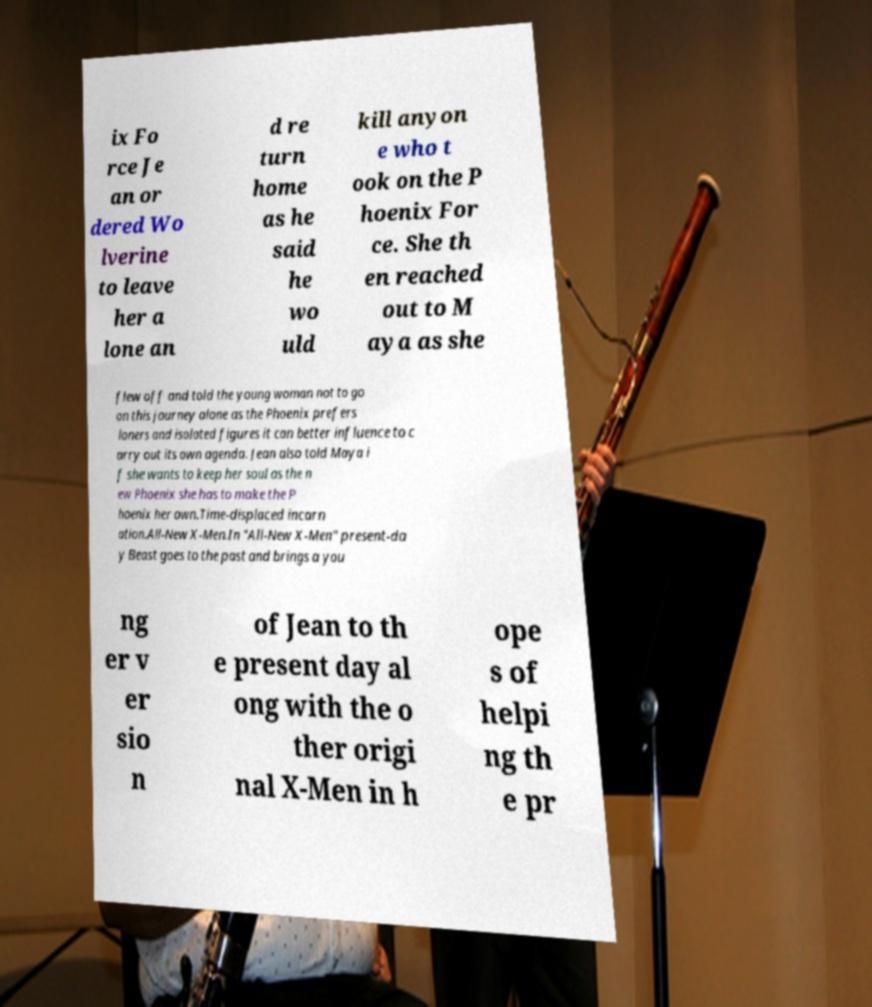There's text embedded in this image that I need extracted. Can you transcribe it verbatim? ix Fo rce Je an or dered Wo lverine to leave her a lone an d re turn home as he said he wo uld kill anyon e who t ook on the P hoenix For ce. She th en reached out to M aya as she flew off and told the young woman not to go on this journey alone as the Phoenix prefers loners and isolated figures it can better influence to c arry out its own agenda. Jean also told Maya i f she wants to keep her soul as the n ew Phoenix she has to make the P hoenix her own.Time-displaced incarn ation.All-New X-Men.In "All-New X-Men" present-da y Beast goes to the past and brings a you ng er v er sio n of Jean to th e present day al ong with the o ther origi nal X-Men in h ope s of helpi ng th e pr 